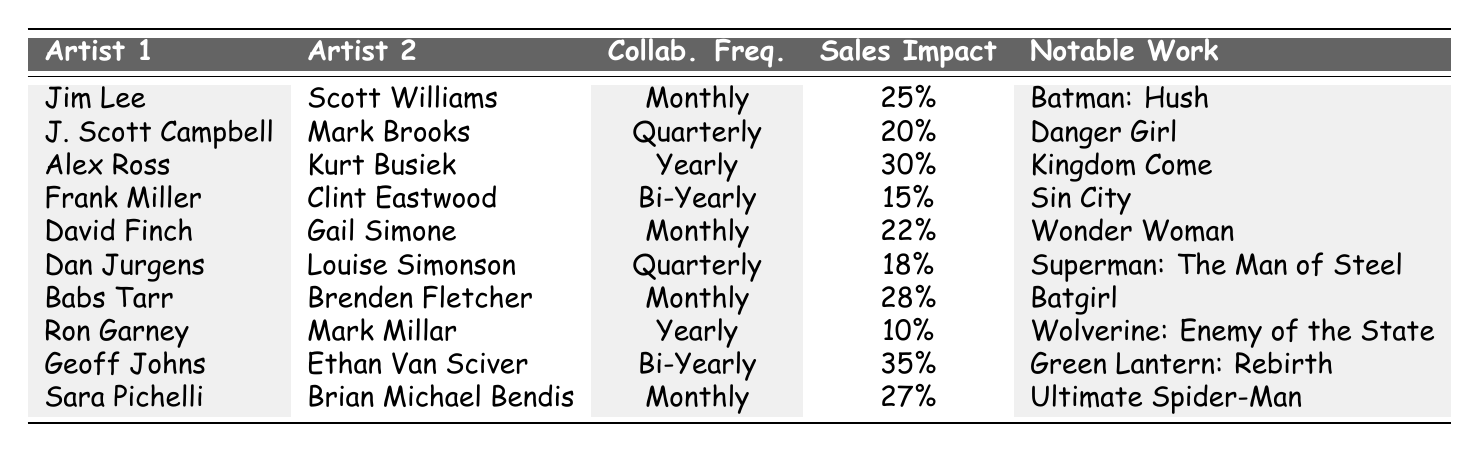What is the collaboration frequency of Jim Lee and Scott Williams? The table specifies that the collaboration frequency for Jim Lee and Scott Williams is listed under the "Collab. Freq." column, which shows "Monthly."
Answer: Monthly Which collaboration has the highest sales impact percent? By examining the "Sales Impact" column, Geoff Johns and Ethan Van Sciver's collaboration shows the highest value at 35%.
Answer: 35% How many artists are collaborating monthly? The table can be scanned for "Collab. Freq." values, counting the rows that are marked as "Monthly," which are Jim Lee & Scott Williams, David Finch & Gail Simone, Babs Tarr & Brenden Fletcher, and Sara Pichelli & Brian Michael Bendis—making a total of 4 collaborations.
Answer: 4 What is the average sales impact percent for all collaborations? To find the average, sum all the "Sales Impact" values (25 + 20 + 30 + 15 + 22 + 18 + 28 + 10 + 35 + 27) =  25 + 20 + 30 + 15 + 22 + 18 + 28 + 10 + 35 + 27 =  255, then divide by the number of collaborations, which is 10, resulting in an average of 255 / 10 = 25.5.
Answer: 25.5 Does any collaboration happen bi-yearly with a sales impact greater than 20%? By checking the "Collab. Freq." column for "Bi-Yearly" and then looking at the respective "Sales Impact" values, we see that Geoff Johns and Ethan Van Sciver have a sales impact of 35%, which is greater than 20%. Therefore, the answer is yes.
Answer: Yes Which artists have collaborated the least frequently? Comparing the frequency of collaborations, Ron Garney and Mark Millar, and Frank Miller and Clint Eastwood collaborate "Yearly" and "Bi-Yearly," respectively. Yearly is more frequent than bi-yearly but less frequent than monthly or quarterly. Hence, the ones who collaborate least frequently are Frank Miller & Clint Eastwood.
Answer: Frank Miller & Clint Eastwood Is there a correlation between collaboration frequency and sales impact? To determine this, we would analyze the frequencies and corresponding sales impacts: higher frequencies (like monthly) generally correlate with higher sales impacts (25%, 22%, 28%, 27%), while yearly and bi-yearly have lower impacts, suggesting a potential correlation that needs deeper analysis.
Answer: Yes Which two artists have the most notable work? Looking in the "Notable Work" column, the notable works are Batman: Hush and Green Lantern: Rebirth, associated with Jim Lee & Scott Williams and Geoff Johns & Ethan Van Sciver, respectively. Both works are highly acclaimed, showcasing significant collaboration impact.
Answer: Batman: Hush and Green Lantern: Rebirth 